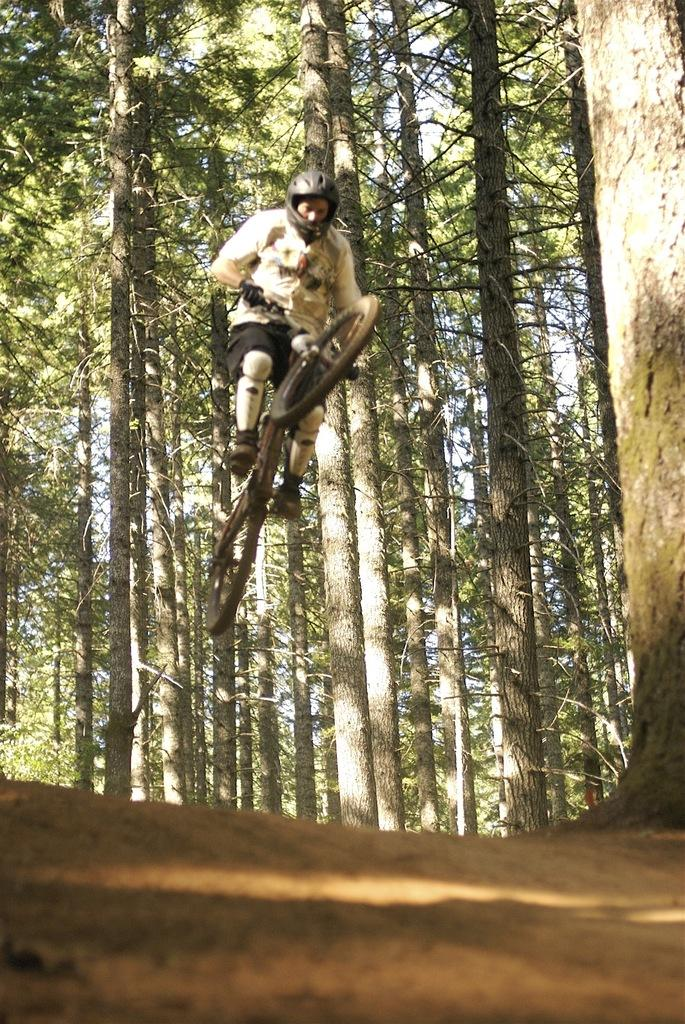Who is the main subject in the image? There is a man in the image. What is the man doing in the image? The man is on a bicycle and performing stunts. What can be seen in the background of the image? There are trees in the background of the image. Where is the drawer located in the image? There is no drawer present in the image. What decision is the man making in the image? The image does not show the man making a decision; it shows him performing stunts on a bicycle. 